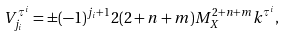Convert formula to latex. <formula><loc_0><loc_0><loc_500><loc_500>V ^ { \tau ^ { i } } _ { j _ { i } } = \pm ( - 1 ) ^ { j _ { i } + 1 } 2 ( 2 + n + m ) M _ { X } ^ { 2 + n + m } k ^ { \tau ^ { i } } , \,</formula> 